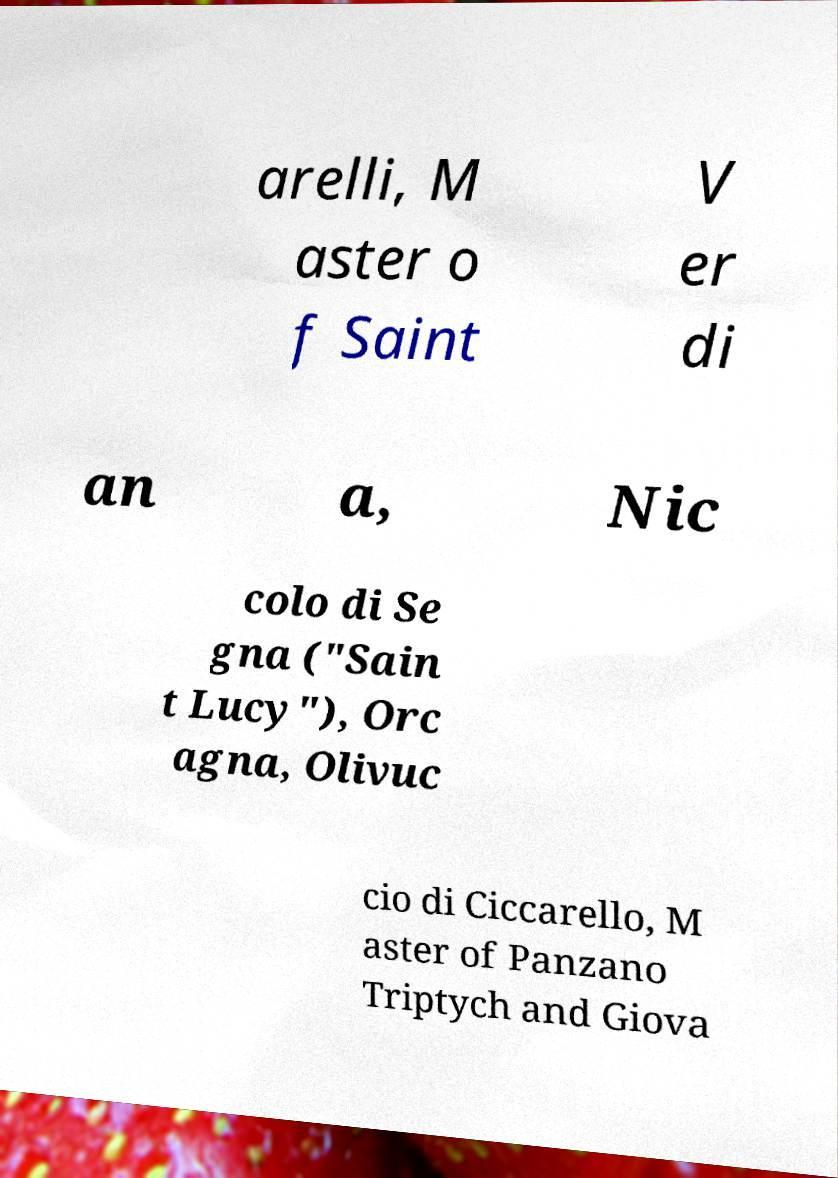What messages or text are displayed in this image? I need them in a readable, typed format. arelli, M aster o f Saint V er di an a, Nic colo di Se gna ("Sain t Lucy"), Orc agna, Olivuc cio di Ciccarello, M aster of Panzano Triptych and Giova 